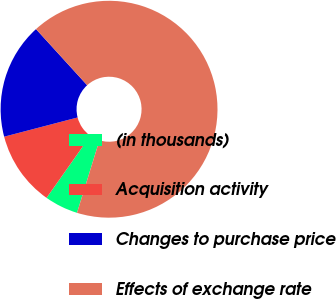Convert chart. <chart><loc_0><loc_0><loc_500><loc_500><pie_chart><fcel>(in thousands)<fcel>Acquisition activity<fcel>Changes to purchase price<fcel>Effects of exchange rate<nl><fcel>5.0%<fcel>11.15%<fcel>17.31%<fcel>66.54%<nl></chart> 